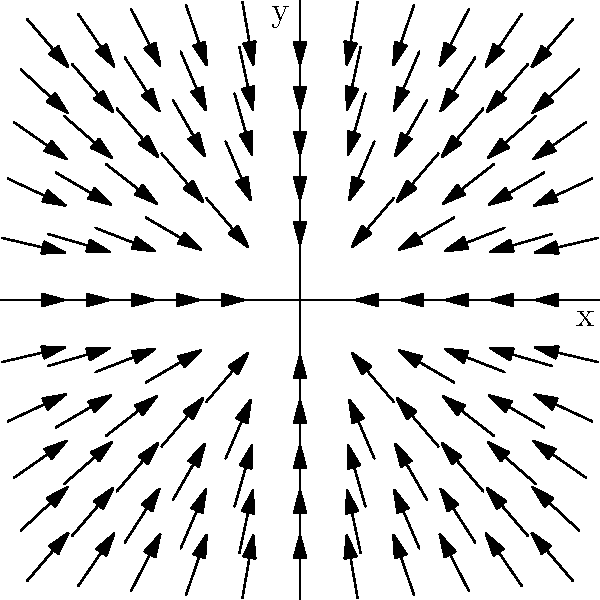The town's irrigation system can be modeled using a vector field. The above diagram shows the flow of water in a section of the system. If a water particle is at position (1, 1), in which direction will it move, and what is the magnitude of its velocity? To solve this problem, we need to follow these steps:

1. Observe the vector field:
   The arrows in the diagram represent the direction and magnitude of the water flow at each point.

2. Identify the vector at (1, 1):
   At the point (1, 1), we can see an arrow pointing up and to the right.

3. Determine the components of the vector:
   The x-component appears to be equal to x, so at (1, 1), it would be 1.
   The y-component appears to be equal to 2y, so at (1, 1), it would be 2.

4. Express the vector:
   The vector at (1, 1) can be written as $\vec{v} = (1, 2)$.

5. Calculate the direction:
   The direction can be found using the arctangent function:
   $\theta = \arctan(\frac{y}{x}) = \arctan(\frac{2}{1}) \approx 63.4°$ from the positive x-axis.

6. Calculate the magnitude:
   The magnitude can be found using the Pythagorean theorem:
   $|\vec{v}| = \sqrt{1^2 + 2^2} = \sqrt{5} \approx 2.24$

Therefore, a water particle at (1, 1) will move in the direction of approximately 63.4° from the positive x-axis, with a velocity magnitude of $\sqrt{5}$.
Answer: Direction: $63.4°$, Magnitude: $\sqrt{5}$ 